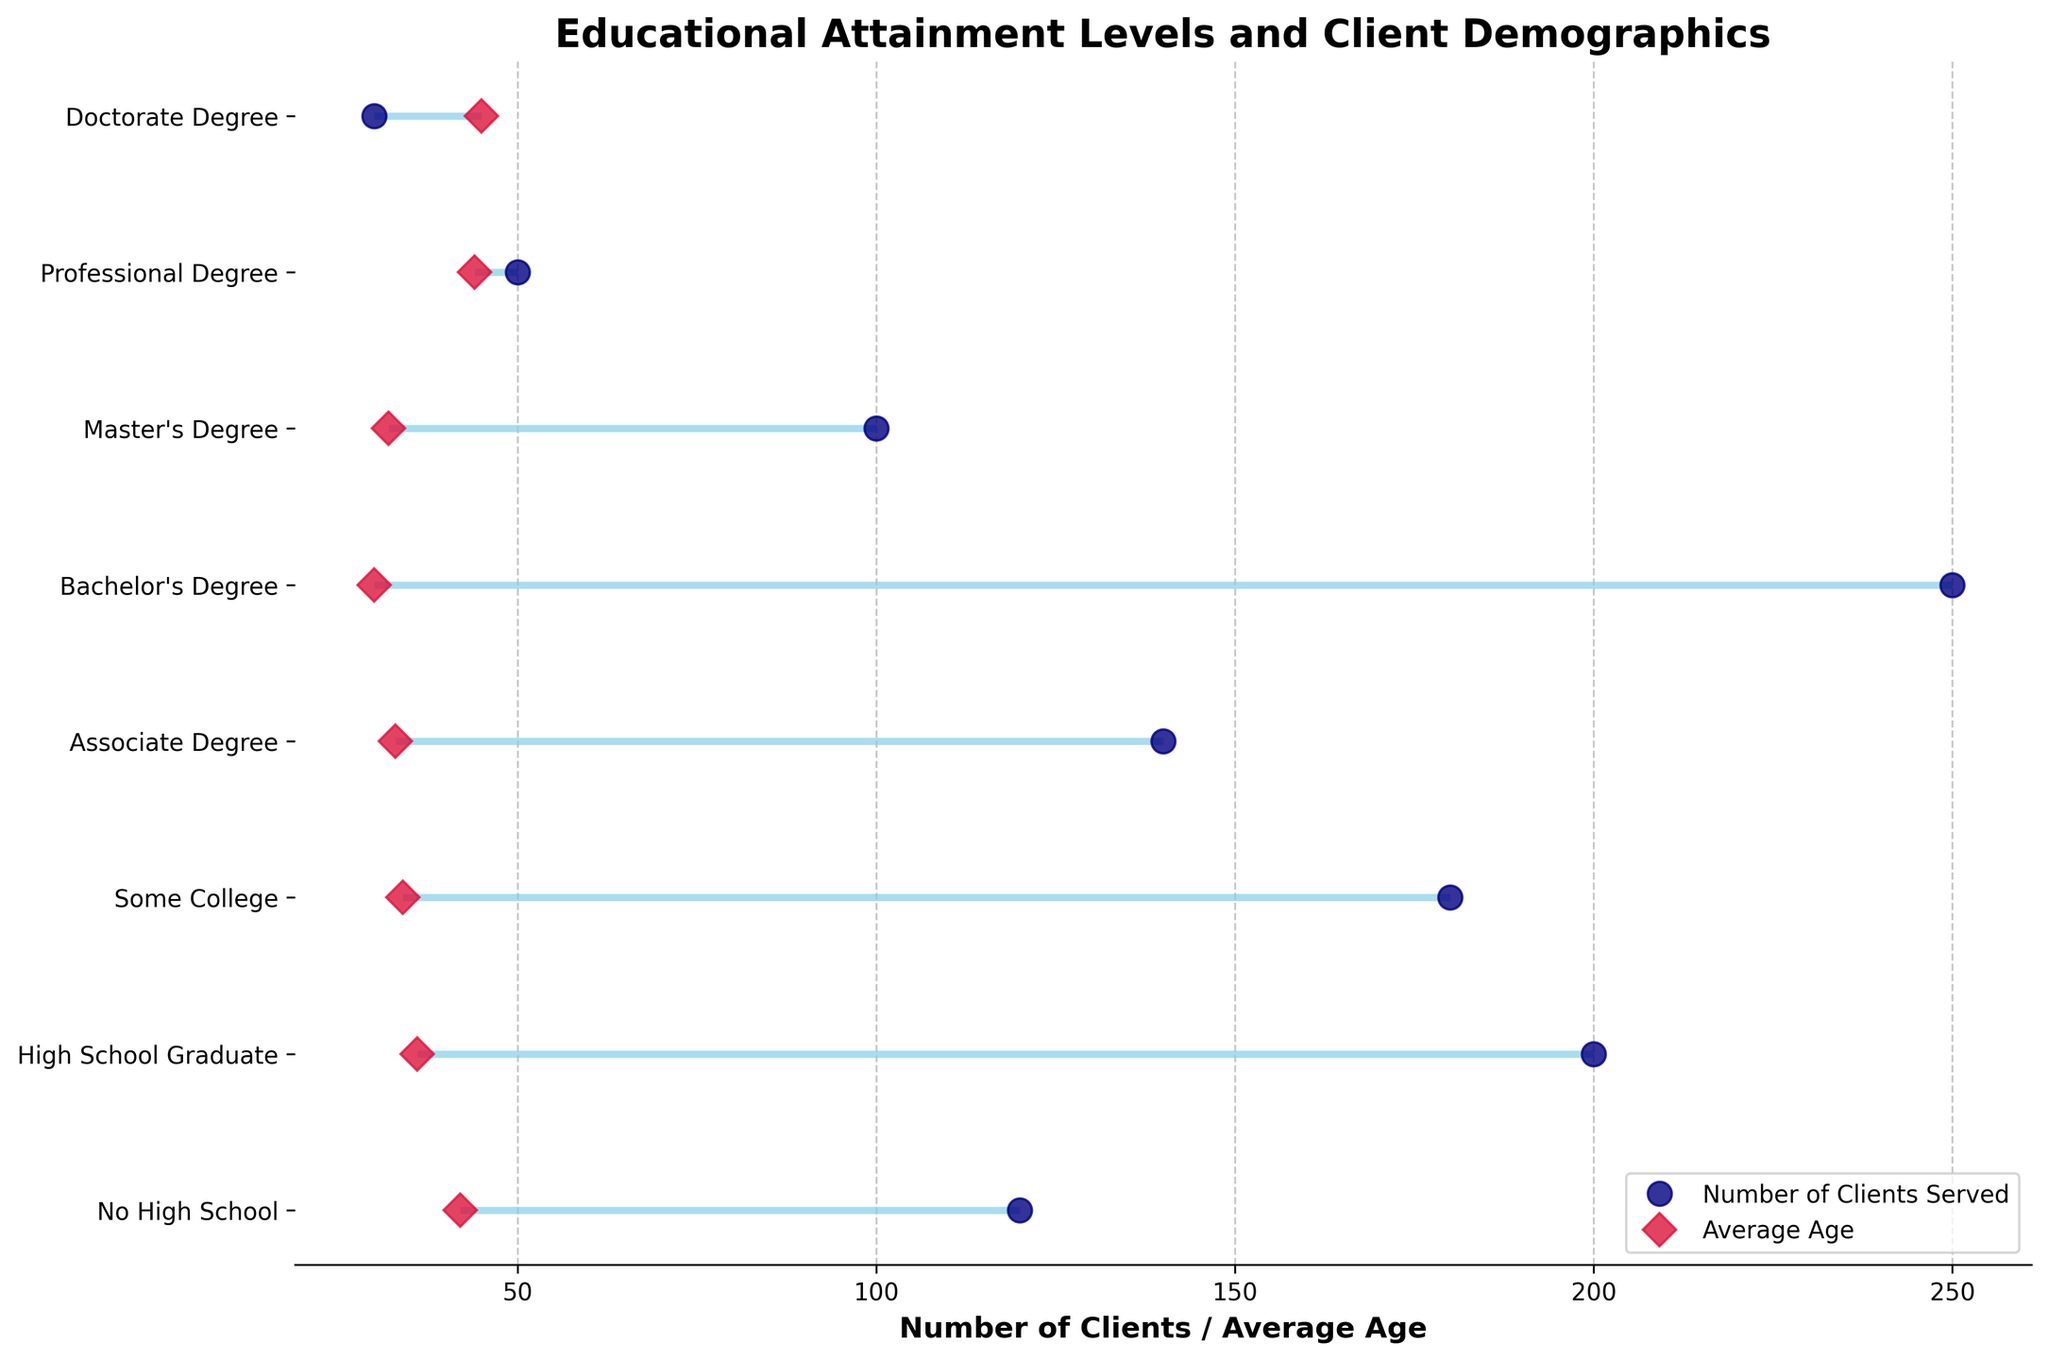What is the title of the plot? The title of the plot is located at the top of the figure, indicating what the plot represents.
Answer: Educational Attainment Levels and Client Demographics How many education levels are displayed in the plot? Count the number of unique labels present on the Y-axis.
Answer: 8 What color is used to represent the Average Age? Observe the figure legend or the color of the markers corresponding to 'Average Age'.
Answer: Crimson What is the maximum number of clients served for any education level, and which level is it? Identify the highest point on the horizontal axis indicating 'Number of Clients Served' and note the corresponding education level label on the Y-axis.
Answer: 250, Bachelor's Degree Which education level has the oldest average age of clients? Look for the highest value marked by the Average Age (crimson marker) on the horizontal axis and identify the corresponding education level on the Y-axis.
Answer: Doctorate Degree What is the range of Number of Clients Served for the High School Graduate education level? Find the 'Number of Clients Served' and 'Average Age' points for "High School Graduate" and calculate the difference.
Answer: 200 - 36 = 164 Compare the average age of clients with a Professional Degree and a Bachelor's Degree. Which one is higher? Look at the crimson markers representing the 'Average Age' for both education levels and compare their positions on the horizontal axis.
Answer: Professional Degree How many education levels have an average age of clients greater than 40? Identify the crimson markers that are greater than 40 and count the number of corresponding education levels on the Y-axis.
Answer: 3 For which education level is the number of clients closest to the average age of clients? Compare the values on the horizontal axis for 'Number of Clients Served' and 'Average Age' and find the smallest difference for corresponding education levels.
Answer: Professional Degree By how many clients does the number of clients served with some College exceed that of those with an Associate Degree? Calculate the difference between the 'Number of Clients Served' for "Some College" and "Associate Degree".
Answer: 180 - 140 = 40 